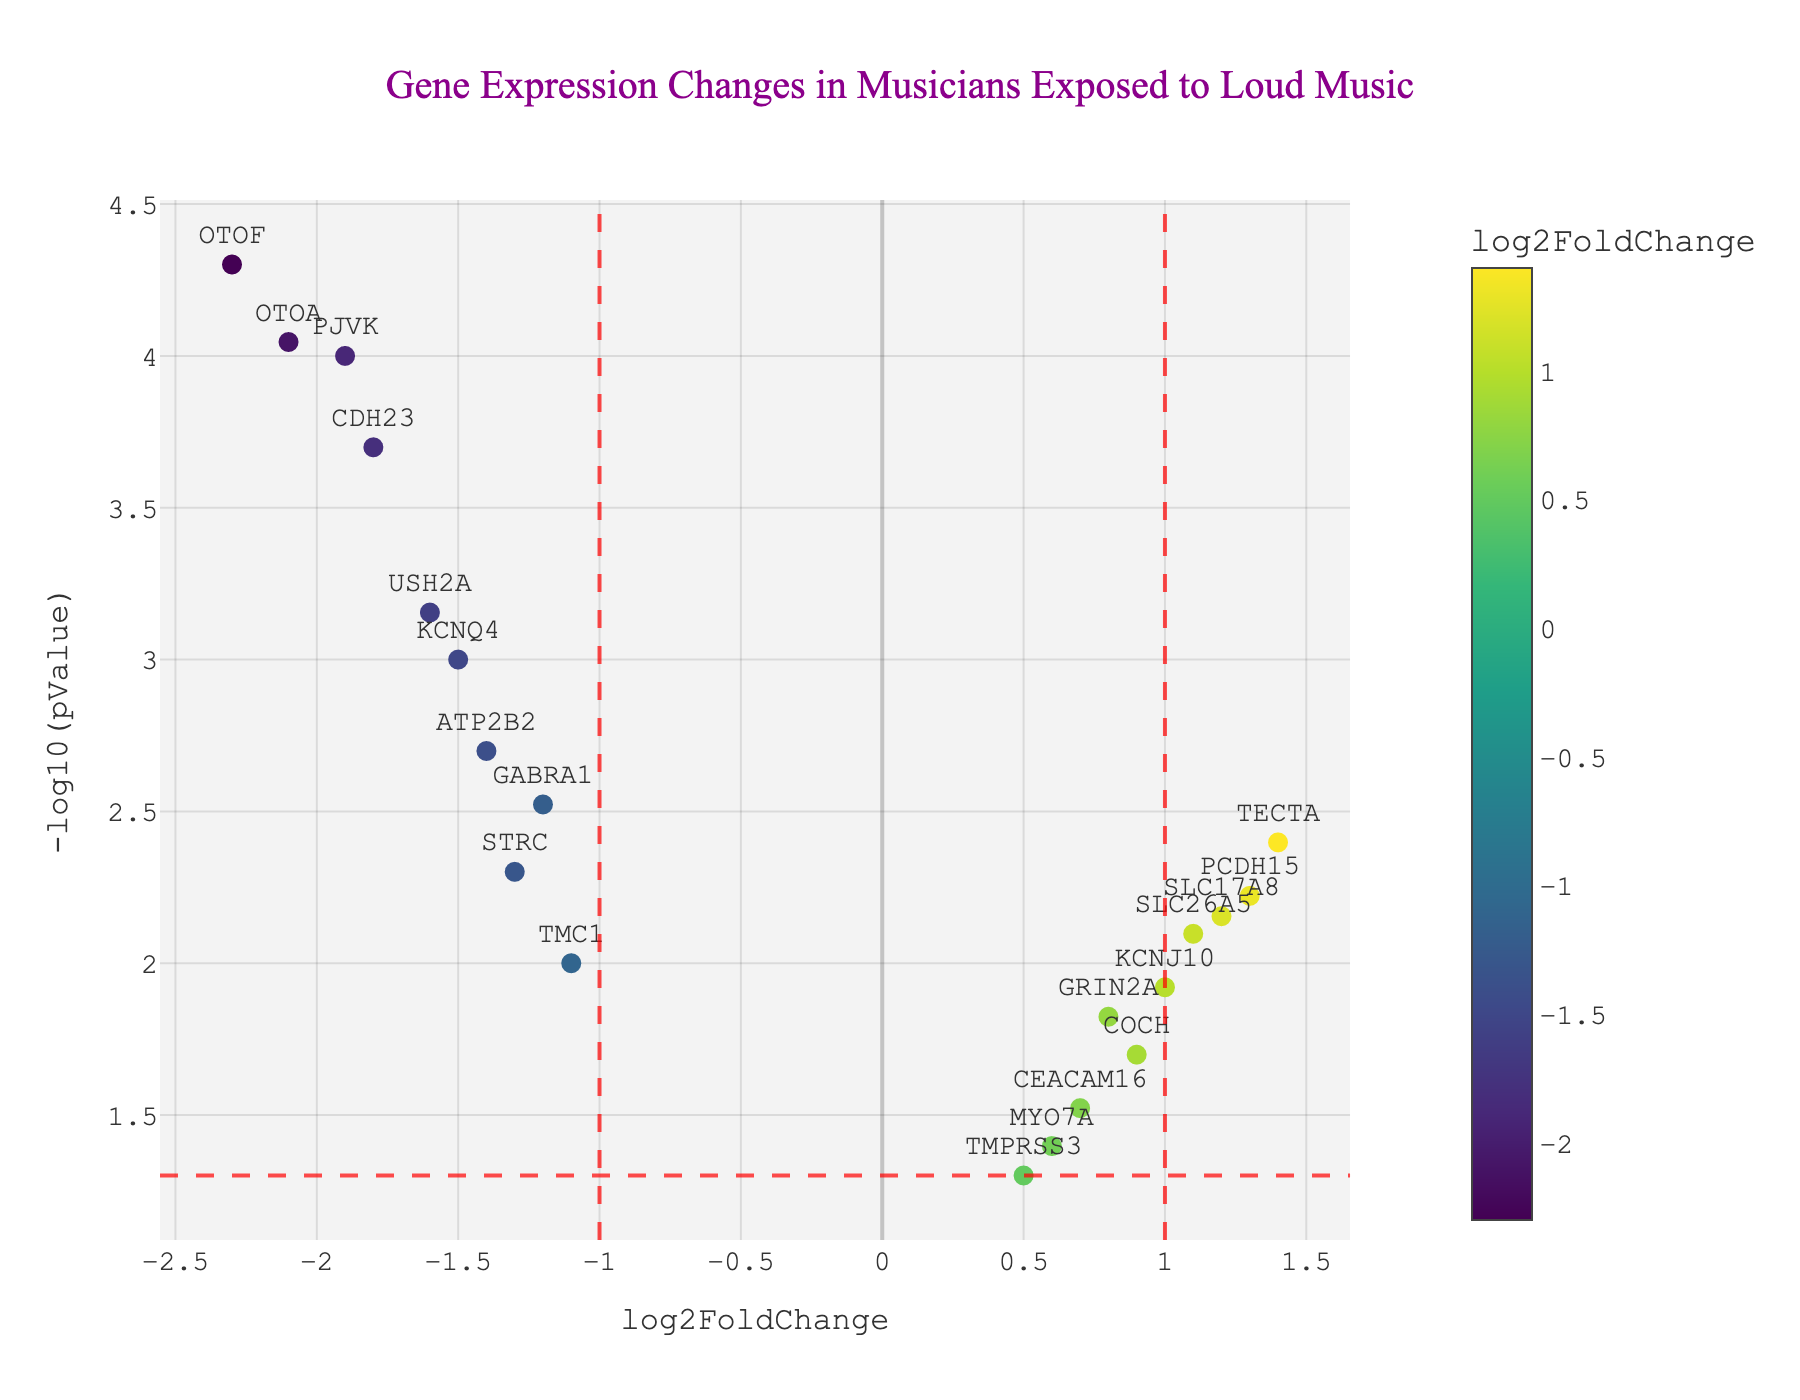What is the title of the figure? The title is often located at the top center of the figure and provides an overview of what the figure represents. Here it mentions gene expression changes in musicians exposed to loud music.
Answer: Gene Expression Changes in Musicians Exposed to Loud Music How many genes have a log2FoldChange greater than 1? By examining the x-axis values, we can identify points to the right of the x=1 vertical line. Counting these points gives the answer.
Answer: 4 genes Which gene has the smallest p-value? The gene with the smallest p-value will have the highest -log10(pValue) value on the y-axis. We find the point with the highest y-axis value and check the corresponding gene label.
Answer: OTOF What does a red dashed vertical line at x=1 signify? This line indicates a threshold for log2FoldChange. Genes to the right have a log2FoldChange greater than 1, suggesting significant upregulation.
Answer: Threshold for significant upregulation Which gene has the highest log2FoldChange? By looking at the x-axis, we find the gene farthest to the right to identify the highest log2FoldChange value.
Answer: TECTA How many genes are significantly downregulated (log2FoldChange < -1 and p-value < 0.05)? We look for points to the left of the x=-1 vertical line and below the y=-log10(0.05) horizontal line, then count these points.
Answer: 6 genes Which gene is labeled at approximately (0.7, 1.55) on the plot? By matching the approximate x and y coordinates to the gene labels in that region, we identify the gene.
Answer: CEACAM16 How many genes are plotted that have a -log10(pValue) > 2? We count all the points above the y=2 line, as this indicates -log10(pValue) values greater than 2.
Answer: 7 genes Which gene is both significantly upregulated and has the highest -log10(pValue)? We want the point to the right of the x=1 line and with the highest y-axis value in that region.
Answer: TECTA 